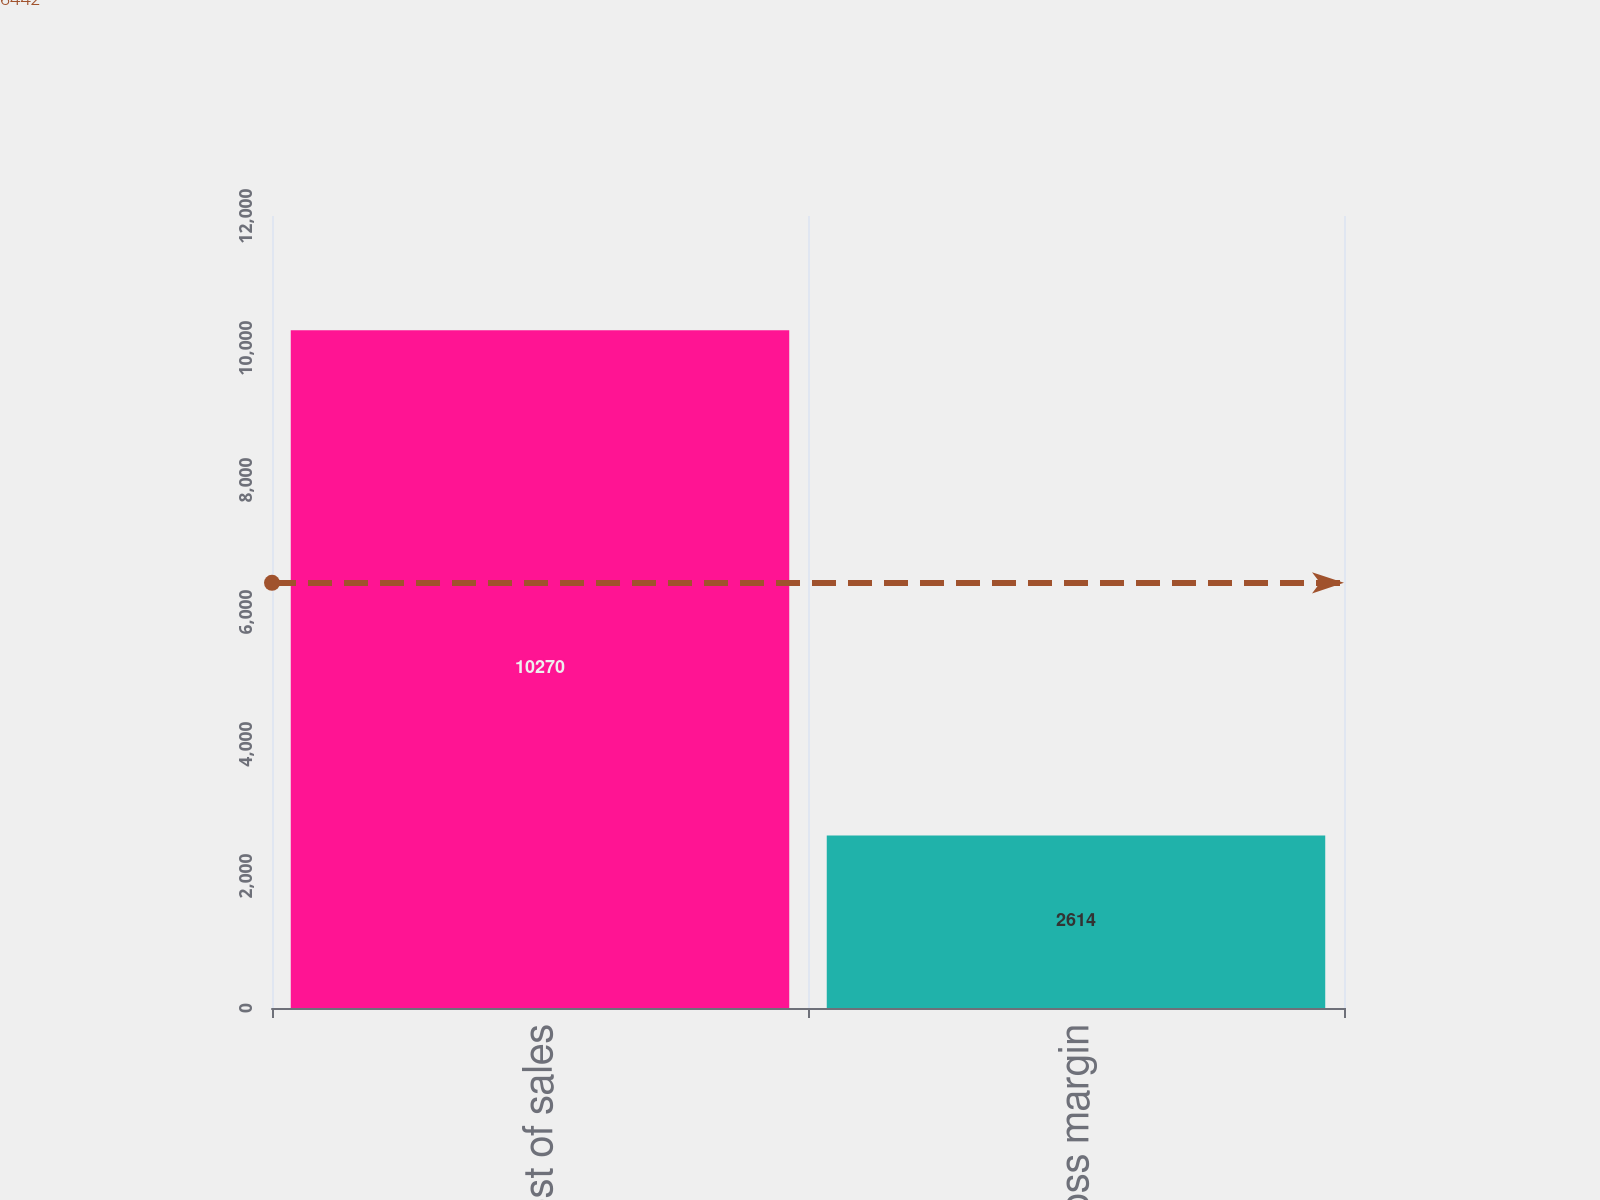Convert chart to OTSL. <chart><loc_0><loc_0><loc_500><loc_500><bar_chart><fcel>Cost of sales<fcel>Gross margin<nl><fcel>10270<fcel>2614<nl></chart> 